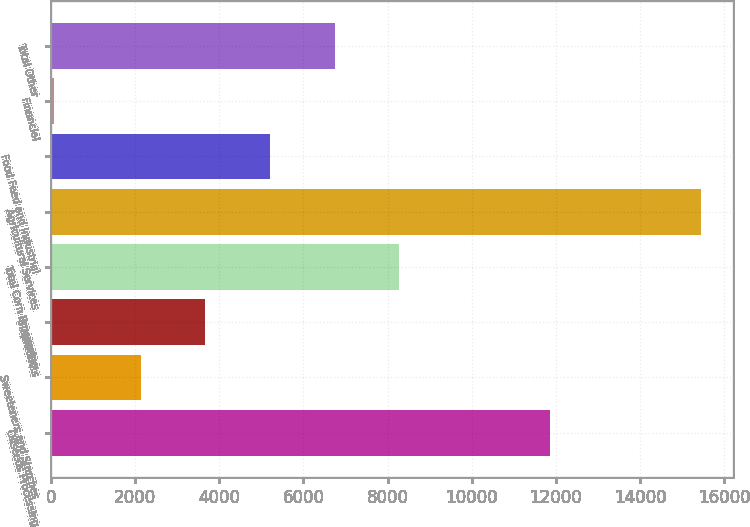Convert chart. <chart><loc_0><loc_0><loc_500><loc_500><bar_chart><fcel>Oilseeds Processing<fcel>Sweeteners and Starches<fcel>Bioproducts<fcel>Total Corn Processing<fcel>Agricultural Services<fcel>Food Feed and Industrial<fcel>Financial<fcel>Total Other<nl><fcel>11867<fcel>2133<fcel>3669.5<fcel>8279<fcel>15440<fcel>5206<fcel>75<fcel>6742.5<nl></chart> 